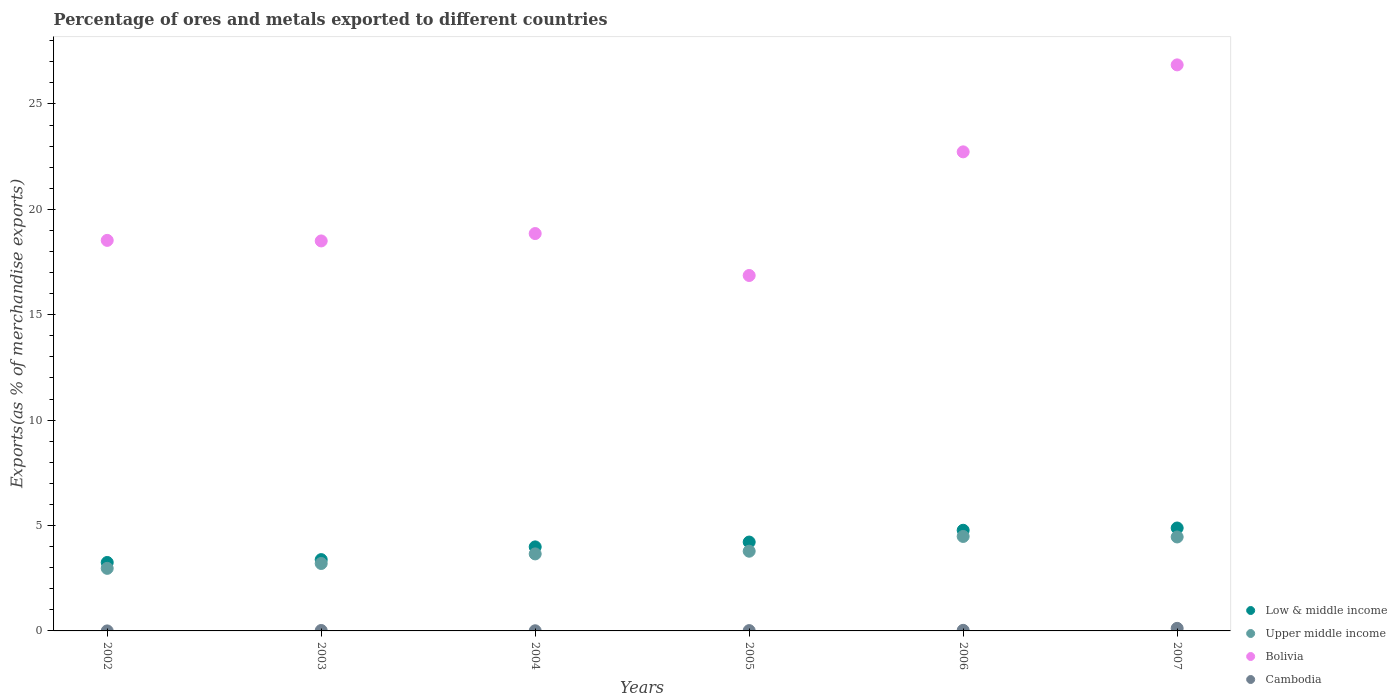How many different coloured dotlines are there?
Your response must be concise. 4. What is the percentage of exports to different countries in Cambodia in 2004?
Make the answer very short. 0.01. Across all years, what is the maximum percentage of exports to different countries in Bolivia?
Ensure brevity in your answer.  26.85. Across all years, what is the minimum percentage of exports to different countries in Cambodia?
Provide a succinct answer. 0. What is the total percentage of exports to different countries in Upper middle income in the graph?
Your response must be concise. 22.54. What is the difference between the percentage of exports to different countries in Low & middle income in 2004 and that in 2006?
Provide a short and direct response. -0.79. What is the difference between the percentage of exports to different countries in Upper middle income in 2004 and the percentage of exports to different countries in Cambodia in 2002?
Keep it short and to the point. 3.65. What is the average percentage of exports to different countries in Upper middle income per year?
Provide a succinct answer. 3.76. In the year 2002, what is the difference between the percentage of exports to different countries in Bolivia and percentage of exports to different countries in Upper middle income?
Your response must be concise. 15.56. In how many years, is the percentage of exports to different countries in Low & middle income greater than 13 %?
Offer a terse response. 0. What is the ratio of the percentage of exports to different countries in Upper middle income in 2002 to that in 2007?
Ensure brevity in your answer.  0.67. What is the difference between the highest and the second highest percentage of exports to different countries in Low & middle income?
Ensure brevity in your answer.  0.11. What is the difference between the highest and the lowest percentage of exports to different countries in Low & middle income?
Your answer should be compact. 1.64. In how many years, is the percentage of exports to different countries in Cambodia greater than the average percentage of exports to different countries in Cambodia taken over all years?
Offer a terse response. 1. Is the sum of the percentage of exports to different countries in Bolivia in 2002 and 2004 greater than the maximum percentage of exports to different countries in Upper middle income across all years?
Keep it short and to the point. Yes. Is it the case that in every year, the sum of the percentage of exports to different countries in Low & middle income and percentage of exports to different countries in Upper middle income  is greater than the sum of percentage of exports to different countries in Bolivia and percentage of exports to different countries in Cambodia?
Provide a succinct answer. No. Is it the case that in every year, the sum of the percentage of exports to different countries in Upper middle income and percentage of exports to different countries in Low & middle income  is greater than the percentage of exports to different countries in Bolivia?
Ensure brevity in your answer.  No. Does the percentage of exports to different countries in Upper middle income monotonically increase over the years?
Offer a very short reply. No. Is the percentage of exports to different countries in Upper middle income strictly greater than the percentage of exports to different countries in Cambodia over the years?
Ensure brevity in your answer.  Yes. Is the percentage of exports to different countries in Cambodia strictly less than the percentage of exports to different countries in Bolivia over the years?
Make the answer very short. Yes. How many years are there in the graph?
Your answer should be compact. 6. What is the difference between two consecutive major ticks on the Y-axis?
Your response must be concise. 5. Does the graph contain grids?
Your answer should be very brief. No. Where does the legend appear in the graph?
Your answer should be compact. Bottom right. How many legend labels are there?
Make the answer very short. 4. What is the title of the graph?
Give a very brief answer. Percentage of ores and metals exported to different countries. Does "Tuvalu" appear as one of the legend labels in the graph?
Offer a very short reply. No. What is the label or title of the Y-axis?
Provide a succinct answer. Exports(as % of merchandise exports). What is the Exports(as % of merchandise exports) in Low & middle income in 2002?
Make the answer very short. 3.25. What is the Exports(as % of merchandise exports) of Upper middle income in 2002?
Make the answer very short. 2.97. What is the Exports(as % of merchandise exports) of Bolivia in 2002?
Offer a terse response. 18.53. What is the Exports(as % of merchandise exports) of Cambodia in 2002?
Ensure brevity in your answer.  0. What is the Exports(as % of merchandise exports) in Low & middle income in 2003?
Your answer should be very brief. 3.38. What is the Exports(as % of merchandise exports) of Upper middle income in 2003?
Ensure brevity in your answer.  3.2. What is the Exports(as % of merchandise exports) of Bolivia in 2003?
Provide a succinct answer. 18.5. What is the Exports(as % of merchandise exports) in Cambodia in 2003?
Offer a very short reply. 0.02. What is the Exports(as % of merchandise exports) of Low & middle income in 2004?
Ensure brevity in your answer.  3.99. What is the Exports(as % of merchandise exports) in Upper middle income in 2004?
Ensure brevity in your answer.  3.65. What is the Exports(as % of merchandise exports) of Bolivia in 2004?
Offer a very short reply. 18.85. What is the Exports(as % of merchandise exports) in Cambodia in 2004?
Give a very brief answer. 0.01. What is the Exports(as % of merchandise exports) of Low & middle income in 2005?
Offer a very short reply. 4.22. What is the Exports(as % of merchandise exports) in Upper middle income in 2005?
Your answer should be compact. 3.78. What is the Exports(as % of merchandise exports) of Bolivia in 2005?
Your answer should be very brief. 16.86. What is the Exports(as % of merchandise exports) of Cambodia in 2005?
Your answer should be very brief. 0.01. What is the Exports(as % of merchandise exports) in Low & middle income in 2006?
Provide a succinct answer. 4.77. What is the Exports(as % of merchandise exports) in Upper middle income in 2006?
Give a very brief answer. 4.48. What is the Exports(as % of merchandise exports) of Bolivia in 2006?
Offer a very short reply. 22.73. What is the Exports(as % of merchandise exports) of Cambodia in 2006?
Offer a very short reply. 0.03. What is the Exports(as % of merchandise exports) of Low & middle income in 2007?
Your answer should be compact. 4.88. What is the Exports(as % of merchandise exports) in Upper middle income in 2007?
Your response must be concise. 4.46. What is the Exports(as % of merchandise exports) of Bolivia in 2007?
Offer a terse response. 26.85. What is the Exports(as % of merchandise exports) of Cambodia in 2007?
Your answer should be compact. 0.12. Across all years, what is the maximum Exports(as % of merchandise exports) in Low & middle income?
Offer a very short reply. 4.88. Across all years, what is the maximum Exports(as % of merchandise exports) of Upper middle income?
Provide a succinct answer. 4.48. Across all years, what is the maximum Exports(as % of merchandise exports) of Bolivia?
Your answer should be compact. 26.85. Across all years, what is the maximum Exports(as % of merchandise exports) of Cambodia?
Offer a very short reply. 0.12. Across all years, what is the minimum Exports(as % of merchandise exports) of Low & middle income?
Give a very brief answer. 3.25. Across all years, what is the minimum Exports(as % of merchandise exports) of Upper middle income?
Your response must be concise. 2.97. Across all years, what is the minimum Exports(as % of merchandise exports) of Bolivia?
Make the answer very short. 16.86. Across all years, what is the minimum Exports(as % of merchandise exports) in Cambodia?
Give a very brief answer. 0. What is the total Exports(as % of merchandise exports) of Low & middle income in the graph?
Offer a very short reply. 24.49. What is the total Exports(as % of merchandise exports) of Upper middle income in the graph?
Offer a very short reply. 22.54. What is the total Exports(as % of merchandise exports) of Bolivia in the graph?
Provide a short and direct response. 122.32. What is the total Exports(as % of merchandise exports) of Cambodia in the graph?
Provide a succinct answer. 0.19. What is the difference between the Exports(as % of merchandise exports) in Low & middle income in 2002 and that in 2003?
Ensure brevity in your answer.  -0.14. What is the difference between the Exports(as % of merchandise exports) in Upper middle income in 2002 and that in 2003?
Provide a short and direct response. -0.23. What is the difference between the Exports(as % of merchandise exports) in Bolivia in 2002 and that in 2003?
Your response must be concise. 0.03. What is the difference between the Exports(as % of merchandise exports) in Cambodia in 2002 and that in 2003?
Ensure brevity in your answer.  -0.02. What is the difference between the Exports(as % of merchandise exports) in Low & middle income in 2002 and that in 2004?
Give a very brief answer. -0.74. What is the difference between the Exports(as % of merchandise exports) of Upper middle income in 2002 and that in 2004?
Offer a terse response. -0.69. What is the difference between the Exports(as % of merchandise exports) in Bolivia in 2002 and that in 2004?
Offer a terse response. -0.32. What is the difference between the Exports(as % of merchandise exports) of Cambodia in 2002 and that in 2004?
Provide a short and direct response. -0.01. What is the difference between the Exports(as % of merchandise exports) in Low & middle income in 2002 and that in 2005?
Your answer should be compact. -0.97. What is the difference between the Exports(as % of merchandise exports) of Upper middle income in 2002 and that in 2005?
Provide a succinct answer. -0.81. What is the difference between the Exports(as % of merchandise exports) of Bolivia in 2002 and that in 2005?
Keep it short and to the point. 1.67. What is the difference between the Exports(as % of merchandise exports) of Cambodia in 2002 and that in 2005?
Provide a succinct answer. -0.01. What is the difference between the Exports(as % of merchandise exports) of Low & middle income in 2002 and that in 2006?
Your answer should be very brief. -1.53. What is the difference between the Exports(as % of merchandise exports) in Upper middle income in 2002 and that in 2006?
Make the answer very short. -1.51. What is the difference between the Exports(as % of merchandise exports) in Bolivia in 2002 and that in 2006?
Provide a succinct answer. -4.2. What is the difference between the Exports(as % of merchandise exports) of Cambodia in 2002 and that in 2006?
Make the answer very short. -0.03. What is the difference between the Exports(as % of merchandise exports) of Low & middle income in 2002 and that in 2007?
Your answer should be compact. -1.64. What is the difference between the Exports(as % of merchandise exports) in Upper middle income in 2002 and that in 2007?
Provide a short and direct response. -1.49. What is the difference between the Exports(as % of merchandise exports) of Bolivia in 2002 and that in 2007?
Keep it short and to the point. -8.33. What is the difference between the Exports(as % of merchandise exports) of Cambodia in 2002 and that in 2007?
Give a very brief answer. -0.12. What is the difference between the Exports(as % of merchandise exports) in Low & middle income in 2003 and that in 2004?
Your answer should be compact. -0.6. What is the difference between the Exports(as % of merchandise exports) of Upper middle income in 2003 and that in 2004?
Offer a very short reply. -0.45. What is the difference between the Exports(as % of merchandise exports) of Bolivia in 2003 and that in 2004?
Give a very brief answer. -0.35. What is the difference between the Exports(as % of merchandise exports) in Cambodia in 2003 and that in 2004?
Give a very brief answer. 0.01. What is the difference between the Exports(as % of merchandise exports) of Low & middle income in 2003 and that in 2005?
Keep it short and to the point. -0.83. What is the difference between the Exports(as % of merchandise exports) of Upper middle income in 2003 and that in 2005?
Make the answer very short. -0.58. What is the difference between the Exports(as % of merchandise exports) of Bolivia in 2003 and that in 2005?
Your answer should be very brief. 1.64. What is the difference between the Exports(as % of merchandise exports) of Cambodia in 2003 and that in 2005?
Your answer should be compact. 0.01. What is the difference between the Exports(as % of merchandise exports) in Low & middle income in 2003 and that in 2006?
Your answer should be compact. -1.39. What is the difference between the Exports(as % of merchandise exports) of Upper middle income in 2003 and that in 2006?
Offer a terse response. -1.28. What is the difference between the Exports(as % of merchandise exports) of Bolivia in 2003 and that in 2006?
Your response must be concise. -4.23. What is the difference between the Exports(as % of merchandise exports) in Cambodia in 2003 and that in 2006?
Your answer should be compact. -0.01. What is the difference between the Exports(as % of merchandise exports) in Low & middle income in 2003 and that in 2007?
Give a very brief answer. -1.5. What is the difference between the Exports(as % of merchandise exports) in Upper middle income in 2003 and that in 2007?
Offer a terse response. -1.26. What is the difference between the Exports(as % of merchandise exports) in Bolivia in 2003 and that in 2007?
Make the answer very short. -8.35. What is the difference between the Exports(as % of merchandise exports) of Cambodia in 2003 and that in 2007?
Offer a terse response. -0.1. What is the difference between the Exports(as % of merchandise exports) of Low & middle income in 2004 and that in 2005?
Provide a succinct answer. -0.23. What is the difference between the Exports(as % of merchandise exports) in Upper middle income in 2004 and that in 2005?
Ensure brevity in your answer.  -0.13. What is the difference between the Exports(as % of merchandise exports) of Bolivia in 2004 and that in 2005?
Offer a terse response. 1.99. What is the difference between the Exports(as % of merchandise exports) of Cambodia in 2004 and that in 2005?
Your response must be concise. -0.01. What is the difference between the Exports(as % of merchandise exports) of Low & middle income in 2004 and that in 2006?
Ensure brevity in your answer.  -0.79. What is the difference between the Exports(as % of merchandise exports) of Upper middle income in 2004 and that in 2006?
Offer a terse response. -0.83. What is the difference between the Exports(as % of merchandise exports) in Bolivia in 2004 and that in 2006?
Offer a terse response. -3.88. What is the difference between the Exports(as % of merchandise exports) of Cambodia in 2004 and that in 2006?
Your response must be concise. -0.02. What is the difference between the Exports(as % of merchandise exports) in Low & middle income in 2004 and that in 2007?
Give a very brief answer. -0.9. What is the difference between the Exports(as % of merchandise exports) of Upper middle income in 2004 and that in 2007?
Your answer should be compact. -0.8. What is the difference between the Exports(as % of merchandise exports) of Bolivia in 2004 and that in 2007?
Give a very brief answer. -8. What is the difference between the Exports(as % of merchandise exports) in Cambodia in 2004 and that in 2007?
Provide a succinct answer. -0.11. What is the difference between the Exports(as % of merchandise exports) in Low & middle income in 2005 and that in 2006?
Keep it short and to the point. -0.56. What is the difference between the Exports(as % of merchandise exports) in Upper middle income in 2005 and that in 2006?
Give a very brief answer. -0.7. What is the difference between the Exports(as % of merchandise exports) of Bolivia in 2005 and that in 2006?
Offer a very short reply. -5.87. What is the difference between the Exports(as % of merchandise exports) of Cambodia in 2005 and that in 2006?
Keep it short and to the point. -0.01. What is the difference between the Exports(as % of merchandise exports) in Low & middle income in 2005 and that in 2007?
Offer a very short reply. -0.67. What is the difference between the Exports(as % of merchandise exports) of Upper middle income in 2005 and that in 2007?
Make the answer very short. -0.68. What is the difference between the Exports(as % of merchandise exports) of Bolivia in 2005 and that in 2007?
Provide a short and direct response. -9.99. What is the difference between the Exports(as % of merchandise exports) of Cambodia in 2005 and that in 2007?
Your response must be concise. -0.11. What is the difference between the Exports(as % of merchandise exports) in Low & middle income in 2006 and that in 2007?
Your answer should be very brief. -0.11. What is the difference between the Exports(as % of merchandise exports) of Upper middle income in 2006 and that in 2007?
Give a very brief answer. 0.02. What is the difference between the Exports(as % of merchandise exports) of Bolivia in 2006 and that in 2007?
Ensure brevity in your answer.  -4.13. What is the difference between the Exports(as % of merchandise exports) in Cambodia in 2006 and that in 2007?
Keep it short and to the point. -0.09. What is the difference between the Exports(as % of merchandise exports) of Low & middle income in 2002 and the Exports(as % of merchandise exports) of Upper middle income in 2003?
Ensure brevity in your answer.  0.05. What is the difference between the Exports(as % of merchandise exports) of Low & middle income in 2002 and the Exports(as % of merchandise exports) of Bolivia in 2003?
Offer a very short reply. -15.25. What is the difference between the Exports(as % of merchandise exports) of Low & middle income in 2002 and the Exports(as % of merchandise exports) of Cambodia in 2003?
Offer a terse response. 3.23. What is the difference between the Exports(as % of merchandise exports) in Upper middle income in 2002 and the Exports(as % of merchandise exports) in Bolivia in 2003?
Ensure brevity in your answer.  -15.53. What is the difference between the Exports(as % of merchandise exports) in Upper middle income in 2002 and the Exports(as % of merchandise exports) in Cambodia in 2003?
Ensure brevity in your answer.  2.95. What is the difference between the Exports(as % of merchandise exports) in Bolivia in 2002 and the Exports(as % of merchandise exports) in Cambodia in 2003?
Your response must be concise. 18.51. What is the difference between the Exports(as % of merchandise exports) of Low & middle income in 2002 and the Exports(as % of merchandise exports) of Upper middle income in 2004?
Provide a short and direct response. -0.41. What is the difference between the Exports(as % of merchandise exports) in Low & middle income in 2002 and the Exports(as % of merchandise exports) in Bolivia in 2004?
Offer a very short reply. -15.6. What is the difference between the Exports(as % of merchandise exports) in Low & middle income in 2002 and the Exports(as % of merchandise exports) in Cambodia in 2004?
Your response must be concise. 3.24. What is the difference between the Exports(as % of merchandise exports) in Upper middle income in 2002 and the Exports(as % of merchandise exports) in Bolivia in 2004?
Ensure brevity in your answer.  -15.88. What is the difference between the Exports(as % of merchandise exports) of Upper middle income in 2002 and the Exports(as % of merchandise exports) of Cambodia in 2004?
Keep it short and to the point. 2.96. What is the difference between the Exports(as % of merchandise exports) in Bolivia in 2002 and the Exports(as % of merchandise exports) in Cambodia in 2004?
Give a very brief answer. 18.52. What is the difference between the Exports(as % of merchandise exports) in Low & middle income in 2002 and the Exports(as % of merchandise exports) in Upper middle income in 2005?
Ensure brevity in your answer.  -0.53. What is the difference between the Exports(as % of merchandise exports) of Low & middle income in 2002 and the Exports(as % of merchandise exports) of Bolivia in 2005?
Offer a very short reply. -13.61. What is the difference between the Exports(as % of merchandise exports) in Low & middle income in 2002 and the Exports(as % of merchandise exports) in Cambodia in 2005?
Provide a short and direct response. 3.23. What is the difference between the Exports(as % of merchandise exports) in Upper middle income in 2002 and the Exports(as % of merchandise exports) in Bolivia in 2005?
Your answer should be very brief. -13.89. What is the difference between the Exports(as % of merchandise exports) of Upper middle income in 2002 and the Exports(as % of merchandise exports) of Cambodia in 2005?
Offer a terse response. 2.95. What is the difference between the Exports(as % of merchandise exports) of Bolivia in 2002 and the Exports(as % of merchandise exports) of Cambodia in 2005?
Give a very brief answer. 18.51. What is the difference between the Exports(as % of merchandise exports) in Low & middle income in 2002 and the Exports(as % of merchandise exports) in Upper middle income in 2006?
Offer a very short reply. -1.23. What is the difference between the Exports(as % of merchandise exports) in Low & middle income in 2002 and the Exports(as % of merchandise exports) in Bolivia in 2006?
Keep it short and to the point. -19.48. What is the difference between the Exports(as % of merchandise exports) of Low & middle income in 2002 and the Exports(as % of merchandise exports) of Cambodia in 2006?
Make the answer very short. 3.22. What is the difference between the Exports(as % of merchandise exports) of Upper middle income in 2002 and the Exports(as % of merchandise exports) of Bolivia in 2006?
Ensure brevity in your answer.  -19.76. What is the difference between the Exports(as % of merchandise exports) of Upper middle income in 2002 and the Exports(as % of merchandise exports) of Cambodia in 2006?
Your answer should be compact. 2.94. What is the difference between the Exports(as % of merchandise exports) of Bolivia in 2002 and the Exports(as % of merchandise exports) of Cambodia in 2006?
Give a very brief answer. 18.5. What is the difference between the Exports(as % of merchandise exports) of Low & middle income in 2002 and the Exports(as % of merchandise exports) of Upper middle income in 2007?
Your answer should be very brief. -1.21. What is the difference between the Exports(as % of merchandise exports) of Low & middle income in 2002 and the Exports(as % of merchandise exports) of Bolivia in 2007?
Your response must be concise. -23.61. What is the difference between the Exports(as % of merchandise exports) of Low & middle income in 2002 and the Exports(as % of merchandise exports) of Cambodia in 2007?
Ensure brevity in your answer.  3.13. What is the difference between the Exports(as % of merchandise exports) of Upper middle income in 2002 and the Exports(as % of merchandise exports) of Bolivia in 2007?
Keep it short and to the point. -23.89. What is the difference between the Exports(as % of merchandise exports) in Upper middle income in 2002 and the Exports(as % of merchandise exports) in Cambodia in 2007?
Offer a very short reply. 2.85. What is the difference between the Exports(as % of merchandise exports) in Bolivia in 2002 and the Exports(as % of merchandise exports) in Cambodia in 2007?
Offer a very short reply. 18.41. What is the difference between the Exports(as % of merchandise exports) in Low & middle income in 2003 and the Exports(as % of merchandise exports) in Upper middle income in 2004?
Make the answer very short. -0.27. What is the difference between the Exports(as % of merchandise exports) of Low & middle income in 2003 and the Exports(as % of merchandise exports) of Bolivia in 2004?
Ensure brevity in your answer.  -15.47. What is the difference between the Exports(as % of merchandise exports) of Low & middle income in 2003 and the Exports(as % of merchandise exports) of Cambodia in 2004?
Provide a short and direct response. 3.38. What is the difference between the Exports(as % of merchandise exports) of Upper middle income in 2003 and the Exports(as % of merchandise exports) of Bolivia in 2004?
Your response must be concise. -15.65. What is the difference between the Exports(as % of merchandise exports) of Upper middle income in 2003 and the Exports(as % of merchandise exports) of Cambodia in 2004?
Your answer should be very brief. 3.19. What is the difference between the Exports(as % of merchandise exports) in Bolivia in 2003 and the Exports(as % of merchandise exports) in Cambodia in 2004?
Your answer should be compact. 18.49. What is the difference between the Exports(as % of merchandise exports) of Low & middle income in 2003 and the Exports(as % of merchandise exports) of Upper middle income in 2005?
Offer a very short reply. -0.4. What is the difference between the Exports(as % of merchandise exports) of Low & middle income in 2003 and the Exports(as % of merchandise exports) of Bolivia in 2005?
Keep it short and to the point. -13.48. What is the difference between the Exports(as % of merchandise exports) in Low & middle income in 2003 and the Exports(as % of merchandise exports) in Cambodia in 2005?
Keep it short and to the point. 3.37. What is the difference between the Exports(as % of merchandise exports) in Upper middle income in 2003 and the Exports(as % of merchandise exports) in Bolivia in 2005?
Keep it short and to the point. -13.66. What is the difference between the Exports(as % of merchandise exports) in Upper middle income in 2003 and the Exports(as % of merchandise exports) in Cambodia in 2005?
Keep it short and to the point. 3.18. What is the difference between the Exports(as % of merchandise exports) in Bolivia in 2003 and the Exports(as % of merchandise exports) in Cambodia in 2005?
Ensure brevity in your answer.  18.49. What is the difference between the Exports(as % of merchandise exports) in Low & middle income in 2003 and the Exports(as % of merchandise exports) in Upper middle income in 2006?
Offer a very short reply. -1.1. What is the difference between the Exports(as % of merchandise exports) of Low & middle income in 2003 and the Exports(as % of merchandise exports) of Bolivia in 2006?
Give a very brief answer. -19.34. What is the difference between the Exports(as % of merchandise exports) in Low & middle income in 2003 and the Exports(as % of merchandise exports) in Cambodia in 2006?
Offer a terse response. 3.36. What is the difference between the Exports(as % of merchandise exports) of Upper middle income in 2003 and the Exports(as % of merchandise exports) of Bolivia in 2006?
Provide a succinct answer. -19.53. What is the difference between the Exports(as % of merchandise exports) of Upper middle income in 2003 and the Exports(as % of merchandise exports) of Cambodia in 2006?
Give a very brief answer. 3.17. What is the difference between the Exports(as % of merchandise exports) in Bolivia in 2003 and the Exports(as % of merchandise exports) in Cambodia in 2006?
Your answer should be very brief. 18.47. What is the difference between the Exports(as % of merchandise exports) of Low & middle income in 2003 and the Exports(as % of merchandise exports) of Upper middle income in 2007?
Offer a very short reply. -1.07. What is the difference between the Exports(as % of merchandise exports) of Low & middle income in 2003 and the Exports(as % of merchandise exports) of Bolivia in 2007?
Your response must be concise. -23.47. What is the difference between the Exports(as % of merchandise exports) of Low & middle income in 2003 and the Exports(as % of merchandise exports) of Cambodia in 2007?
Ensure brevity in your answer.  3.26. What is the difference between the Exports(as % of merchandise exports) in Upper middle income in 2003 and the Exports(as % of merchandise exports) in Bolivia in 2007?
Your response must be concise. -23.65. What is the difference between the Exports(as % of merchandise exports) of Upper middle income in 2003 and the Exports(as % of merchandise exports) of Cambodia in 2007?
Ensure brevity in your answer.  3.08. What is the difference between the Exports(as % of merchandise exports) of Bolivia in 2003 and the Exports(as % of merchandise exports) of Cambodia in 2007?
Ensure brevity in your answer.  18.38. What is the difference between the Exports(as % of merchandise exports) of Low & middle income in 2004 and the Exports(as % of merchandise exports) of Upper middle income in 2005?
Provide a short and direct response. 0.2. What is the difference between the Exports(as % of merchandise exports) in Low & middle income in 2004 and the Exports(as % of merchandise exports) in Bolivia in 2005?
Give a very brief answer. -12.88. What is the difference between the Exports(as % of merchandise exports) in Low & middle income in 2004 and the Exports(as % of merchandise exports) in Cambodia in 2005?
Offer a terse response. 3.97. What is the difference between the Exports(as % of merchandise exports) of Upper middle income in 2004 and the Exports(as % of merchandise exports) of Bolivia in 2005?
Ensure brevity in your answer.  -13.21. What is the difference between the Exports(as % of merchandise exports) in Upper middle income in 2004 and the Exports(as % of merchandise exports) in Cambodia in 2005?
Ensure brevity in your answer.  3.64. What is the difference between the Exports(as % of merchandise exports) of Bolivia in 2004 and the Exports(as % of merchandise exports) of Cambodia in 2005?
Your answer should be compact. 18.84. What is the difference between the Exports(as % of merchandise exports) in Low & middle income in 2004 and the Exports(as % of merchandise exports) in Upper middle income in 2006?
Ensure brevity in your answer.  -0.5. What is the difference between the Exports(as % of merchandise exports) in Low & middle income in 2004 and the Exports(as % of merchandise exports) in Bolivia in 2006?
Offer a very short reply. -18.74. What is the difference between the Exports(as % of merchandise exports) of Low & middle income in 2004 and the Exports(as % of merchandise exports) of Cambodia in 2006?
Your response must be concise. 3.96. What is the difference between the Exports(as % of merchandise exports) of Upper middle income in 2004 and the Exports(as % of merchandise exports) of Bolivia in 2006?
Your answer should be compact. -19.07. What is the difference between the Exports(as % of merchandise exports) of Upper middle income in 2004 and the Exports(as % of merchandise exports) of Cambodia in 2006?
Offer a terse response. 3.63. What is the difference between the Exports(as % of merchandise exports) of Bolivia in 2004 and the Exports(as % of merchandise exports) of Cambodia in 2006?
Keep it short and to the point. 18.82. What is the difference between the Exports(as % of merchandise exports) in Low & middle income in 2004 and the Exports(as % of merchandise exports) in Upper middle income in 2007?
Offer a very short reply. -0.47. What is the difference between the Exports(as % of merchandise exports) in Low & middle income in 2004 and the Exports(as % of merchandise exports) in Bolivia in 2007?
Offer a very short reply. -22.87. What is the difference between the Exports(as % of merchandise exports) in Low & middle income in 2004 and the Exports(as % of merchandise exports) in Cambodia in 2007?
Keep it short and to the point. 3.86. What is the difference between the Exports(as % of merchandise exports) in Upper middle income in 2004 and the Exports(as % of merchandise exports) in Bolivia in 2007?
Your response must be concise. -23.2. What is the difference between the Exports(as % of merchandise exports) in Upper middle income in 2004 and the Exports(as % of merchandise exports) in Cambodia in 2007?
Your answer should be very brief. 3.53. What is the difference between the Exports(as % of merchandise exports) of Bolivia in 2004 and the Exports(as % of merchandise exports) of Cambodia in 2007?
Provide a short and direct response. 18.73. What is the difference between the Exports(as % of merchandise exports) of Low & middle income in 2005 and the Exports(as % of merchandise exports) of Upper middle income in 2006?
Provide a short and direct response. -0.27. What is the difference between the Exports(as % of merchandise exports) in Low & middle income in 2005 and the Exports(as % of merchandise exports) in Bolivia in 2006?
Offer a terse response. -18.51. What is the difference between the Exports(as % of merchandise exports) in Low & middle income in 2005 and the Exports(as % of merchandise exports) in Cambodia in 2006?
Your answer should be compact. 4.19. What is the difference between the Exports(as % of merchandise exports) in Upper middle income in 2005 and the Exports(as % of merchandise exports) in Bolivia in 2006?
Provide a succinct answer. -18.95. What is the difference between the Exports(as % of merchandise exports) in Upper middle income in 2005 and the Exports(as % of merchandise exports) in Cambodia in 2006?
Offer a terse response. 3.75. What is the difference between the Exports(as % of merchandise exports) in Bolivia in 2005 and the Exports(as % of merchandise exports) in Cambodia in 2006?
Offer a very short reply. 16.83. What is the difference between the Exports(as % of merchandise exports) in Low & middle income in 2005 and the Exports(as % of merchandise exports) in Upper middle income in 2007?
Ensure brevity in your answer.  -0.24. What is the difference between the Exports(as % of merchandise exports) in Low & middle income in 2005 and the Exports(as % of merchandise exports) in Bolivia in 2007?
Keep it short and to the point. -22.64. What is the difference between the Exports(as % of merchandise exports) in Low & middle income in 2005 and the Exports(as % of merchandise exports) in Cambodia in 2007?
Provide a succinct answer. 4.09. What is the difference between the Exports(as % of merchandise exports) of Upper middle income in 2005 and the Exports(as % of merchandise exports) of Bolivia in 2007?
Your response must be concise. -23.07. What is the difference between the Exports(as % of merchandise exports) of Upper middle income in 2005 and the Exports(as % of merchandise exports) of Cambodia in 2007?
Your answer should be very brief. 3.66. What is the difference between the Exports(as % of merchandise exports) in Bolivia in 2005 and the Exports(as % of merchandise exports) in Cambodia in 2007?
Keep it short and to the point. 16.74. What is the difference between the Exports(as % of merchandise exports) of Low & middle income in 2006 and the Exports(as % of merchandise exports) of Upper middle income in 2007?
Make the answer very short. 0.32. What is the difference between the Exports(as % of merchandise exports) of Low & middle income in 2006 and the Exports(as % of merchandise exports) of Bolivia in 2007?
Offer a very short reply. -22.08. What is the difference between the Exports(as % of merchandise exports) of Low & middle income in 2006 and the Exports(as % of merchandise exports) of Cambodia in 2007?
Your answer should be compact. 4.65. What is the difference between the Exports(as % of merchandise exports) of Upper middle income in 2006 and the Exports(as % of merchandise exports) of Bolivia in 2007?
Provide a succinct answer. -22.37. What is the difference between the Exports(as % of merchandise exports) in Upper middle income in 2006 and the Exports(as % of merchandise exports) in Cambodia in 2007?
Your answer should be compact. 4.36. What is the difference between the Exports(as % of merchandise exports) of Bolivia in 2006 and the Exports(as % of merchandise exports) of Cambodia in 2007?
Ensure brevity in your answer.  22.61. What is the average Exports(as % of merchandise exports) in Low & middle income per year?
Keep it short and to the point. 4.08. What is the average Exports(as % of merchandise exports) of Upper middle income per year?
Provide a short and direct response. 3.76. What is the average Exports(as % of merchandise exports) in Bolivia per year?
Your response must be concise. 20.39. What is the average Exports(as % of merchandise exports) of Cambodia per year?
Offer a terse response. 0.03. In the year 2002, what is the difference between the Exports(as % of merchandise exports) in Low & middle income and Exports(as % of merchandise exports) in Upper middle income?
Make the answer very short. 0.28. In the year 2002, what is the difference between the Exports(as % of merchandise exports) in Low & middle income and Exports(as % of merchandise exports) in Bolivia?
Make the answer very short. -15.28. In the year 2002, what is the difference between the Exports(as % of merchandise exports) in Low & middle income and Exports(as % of merchandise exports) in Cambodia?
Your answer should be very brief. 3.25. In the year 2002, what is the difference between the Exports(as % of merchandise exports) of Upper middle income and Exports(as % of merchandise exports) of Bolivia?
Give a very brief answer. -15.56. In the year 2002, what is the difference between the Exports(as % of merchandise exports) in Upper middle income and Exports(as % of merchandise exports) in Cambodia?
Make the answer very short. 2.97. In the year 2002, what is the difference between the Exports(as % of merchandise exports) of Bolivia and Exports(as % of merchandise exports) of Cambodia?
Offer a terse response. 18.53. In the year 2003, what is the difference between the Exports(as % of merchandise exports) of Low & middle income and Exports(as % of merchandise exports) of Upper middle income?
Keep it short and to the point. 0.18. In the year 2003, what is the difference between the Exports(as % of merchandise exports) of Low & middle income and Exports(as % of merchandise exports) of Bolivia?
Provide a succinct answer. -15.12. In the year 2003, what is the difference between the Exports(as % of merchandise exports) of Low & middle income and Exports(as % of merchandise exports) of Cambodia?
Your answer should be very brief. 3.36. In the year 2003, what is the difference between the Exports(as % of merchandise exports) of Upper middle income and Exports(as % of merchandise exports) of Bolivia?
Provide a succinct answer. -15.3. In the year 2003, what is the difference between the Exports(as % of merchandise exports) in Upper middle income and Exports(as % of merchandise exports) in Cambodia?
Provide a succinct answer. 3.18. In the year 2003, what is the difference between the Exports(as % of merchandise exports) in Bolivia and Exports(as % of merchandise exports) in Cambodia?
Your response must be concise. 18.48. In the year 2004, what is the difference between the Exports(as % of merchandise exports) in Low & middle income and Exports(as % of merchandise exports) in Upper middle income?
Your response must be concise. 0.33. In the year 2004, what is the difference between the Exports(as % of merchandise exports) of Low & middle income and Exports(as % of merchandise exports) of Bolivia?
Ensure brevity in your answer.  -14.87. In the year 2004, what is the difference between the Exports(as % of merchandise exports) in Low & middle income and Exports(as % of merchandise exports) in Cambodia?
Offer a terse response. 3.98. In the year 2004, what is the difference between the Exports(as % of merchandise exports) of Upper middle income and Exports(as % of merchandise exports) of Bolivia?
Ensure brevity in your answer.  -15.2. In the year 2004, what is the difference between the Exports(as % of merchandise exports) of Upper middle income and Exports(as % of merchandise exports) of Cambodia?
Give a very brief answer. 3.65. In the year 2004, what is the difference between the Exports(as % of merchandise exports) of Bolivia and Exports(as % of merchandise exports) of Cambodia?
Make the answer very short. 18.84. In the year 2005, what is the difference between the Exports(as % of merchandise exports) in Low & middle income and Exports(as % of merchandise exports) in Upper middle income?
Your answer should be very brief. 0.43. In the year 2005, what is the difference between the Exports(as % of merchandise exports) of Low & middle income and Exports(as % of merchandise exports) of Bolivia?
Your response must be concise. -12.65. In the year 2005, what is the difference between the Exports(as % of merchandise exports) in Low & middle income and Exports(as % of merchandise exports) in Cambodia?
Your answer should be very brief. 4.2. In the year 2005, what is the difference between the Exports(as % of merchandise exports) of Upper middle income and Exports(as % of merchandise exports) of Bolivia?
Your response must be concise. -13.08. In the year 2005, what is the difference between the Exports(as % of merchandise exports) in Upper middle income and Exports(as % of merchandise exports) in Cambodia?
Provide a short and direct response. 3.77. In the year 2005, what is the difference between the Exports(as % of merchandise exports) of Bolivia and Exports(as % of merchandise exports) of Cambodia?
Offer a very short reply. 16.85. In the year 2006, what is the difference between the Exports(as % of merchandise exports) of Low & middle income and Exports(as % of merchandise exports) of Upper middle income?
Offer a terse response. 0.29. In the year 2006, what is the difference between the Exports(as % of merchandise exports) in Low & middle income and Exports(as % of merchandise exports) in Bolivia?
Provide a short and direct response. -17.95. In the year 2006, what is the difference between the Exports(as % of merchandise exports) in Low & middle income and Exports(as % of merchandise exports) in Cambodia?
Your response must be concise. 4.75. In the year 2006, what is the difference between the Exports(as % of merchandise exports) in Upper middle income and Exports(as % of merchandise exports) in Bolivia?
Provide a succinct answer. -18.25. In the year 2006, what is the difference between the Exports(as % of merchandise exports) of Upper middle income and Exports(as % of merchandise exports) of Cambodia?
Offer a very short reply. 4.45. In the year 2006, what is the difference between the Exports(as % of merchandise exports) in Bolivia and Exports(as % of merchandise exports) in Cambodia?
Provide a succinct answer. 22.7. In the year 2007, what is the difference between the Exports(as % of merchandise exports) in Low & middle income and Exports(as % of merchandise exports) in Upper middle income?
Offer a terse response. 0.43. In the year 2007, what is the difference between the Exports(as % of merchandise exports) in Low & middle income and Exports(as % of merchandise exports) in Bolivia?
Ensure brevity in your answer.  -21.97. In the year 2007, what is the difference between the Exports(as % of merchandise exports) of Low & middle income and Exports(as % of merchandise exports) of Cambodia?
Make the answer very short. 4.76. In the year 2007, what is the difference between the Exports(as % of merchandise exports) in Upper middle income and Exports(as % of merchandise exports) in Bolivia?
Provide a short and direct response. -22.4. In the year 2007, what is the difference between the Exports(as % of merchandise exports) in Upper middle income and Exports(as % of merchandise exports) in Cambodia?
Your answer should be compact. 4.34. In the year 2007, what is the difference between the Exports(as % of merchandise exports) of Bolivia and Exports(as % of merchandise exports) of Cambodia?
Keep it short and to the point. 26.73. What is the ratio of the Exports(as % of merchandise exports) in Low & middle income in 2002 to that in 2003?
Keep it short and to the point. 0.96. What is the ratio of the Exports(as % of merchandise exports) of Upper middle income in 2002 to that in 2003?
Provide a succinct answer. 0.93. What is the ratio of the Exports(as % of merchandise exports) of Bolivia in 2002 to that in 2003?
Offer a very short reply. 1. What is the ratio of the Exports(as % of merchandise exports) of Cambodia in 2002 to that in 2003?
Provide a short and direct response. 0.03. What is the ratio of the Exports(as % of merchandise exports) in Low & middle income in 2002 to that in 2004?
Keep it short and to the point. 0.81. What is the ratio of the Exports(as % of merchandise exports) of Upper middle income in 2002 to that in 2004?
Your response must be concise. 0.81. What is the ratio of the Exports(as % of merchandise exports) in Bolivia in 2002 to that in 2004?
Provide a succinct answer. 0.98. What is the ratio of the Exports(as % of merchandise exports) of Cambodia in 2002 to that in 2004?
Make the answer very short. 0.08. What is the ratio of the Exports(as % of merchandise exports) of Low & middle income in 2002 to that in 2005?
Ensure brevity in your answer.  0.77. What is the ratio of the Exports(as % of merchandise exports) in Upper middle income in 2002 to that in 2005?
Your response must be concise. 0.78. What is the ratio of the Exports(as % of merchandise exports) of Bolivia in 2002 to that in 2005?
Ensure brevity in your answer.  1.1. What is the ratio of the Exports(as % of merchandise exports) in Cambodia in 2002 to that in 2005?
Make the answer very short. 0.04. What is the ratio of the Exports(as % of merchandise exports) in Low & middle income in 2002 to that in 2006?
Provide a short and direct response. 0.68. What is the ratio of the Exports(as % of merchandise exports) of Upper middle income in 2002 to that in 2006?
Keep it short and to the point. 0.66. What is the ratio of the Exports(as % of merchandise exports) of Bolivia in 2002 to that in 2006?
Your response must be concise. 0.82. What is the ratio of the Exports(as % of merchandise exports) of Cambodia in 2002 to that in 2006?
Your response must be concise. 0.02. What is the ratio of the Exports(as % of merchandise exports) in Low & middle income in 2002 to that in 2007?
Provide a short and direct response. 0.67. What is the ratio of the Exports(as % of merchandise exports) in Upper middle income in 2002 to that in 2007?
Make the answer very short. 0.67. What is the ratio of the Exports(as % of merchandise exports) of Bolivia in 2002 to that in 2007?
Your answer should be very brief. 0.69. What is the ratio of the Exports(as % of merchandise exports) of Cambodia in 2002 to that in 2007?
Provide a short and direct response. 0. What is the ratio of the Exports(as % of merchandise exports) of Low & middle income in 2003 to that in 2004?
Offer a very short reply. 0.85. What is the ratio of the Exports(as % of merchandise exports) in Upper middle income in 2003 to that in 2004?
Give a very brief answer. 0.88. What is the ratio of the Exports(as % of merchandise exports) of Bolivia in 2003 to that in 2004?
Ensure brevity in your answer.  0.98. What is the ratio of the Exports(as % of merchandise exports) in Cambodia in 2003 to that in 2004?
Keep it short and to the point. 2.77. What is the ratio of the Exports(as % of merchandise exports) in Low & middle income in 2003 to that in 2005?
Your answer should be compact. 0.8. What is the ratio of the Exports(as % of merchandise exports) in Upper middle income in 2003 to that in 2005?
Your answer should be compact. 0.85. What is the ratio of the Exports(as % of merchandise exports) in Bolivia in 2003 to that in 2005?
Offer a terse response. 1.1. What is the ratio of the Exports(as % of merchandise exports) in Cambodia in 2003 to that in 2005?
Make the answer very short. 1.35. What is the ratio of the Exports(as % of merchandise exports) of Low & middle income in 2003 to that in 2006?
Provide a succinct answer. 0.71. What is the ratio of the Exports(as % of merchandise exports) in Upper middle income in 2003 to that in 2006?
Offer a very short reply. 0.71. What is the ratio of the Exports(as % of merchandise exports) of Bolivia in 2003 to that in 2006?
Make the answer very short. 0.81. What is the ratio of the Exports(as % of merchandise exports) in Cambodia in 2003 to that in 2006?
Give a very brief answer. 0.73. What is the ratio of the Exports(as % of merchandise exports) of Low & middle income in 2003 to that in 2007?
Make the answer very short. 0.69. What is the ratio of the Exports(as % of merchandise exports) in Upper middle income in 2003 to that in 2007?
Provide a succinct answer. 0.72. What is the ratio of the Exports(as % of merchandise exports) of Bolivia in 2003 to that in 2007?
Ensure brevity in your answer.  0.69. What is the ratio of the Exports(as % of merchandise exports) of Cambodia in 2003 to that in 2007?
Give a very brief answer. 0.17. What is the ratio of the Exports(as % of merchandise exports) in Low & middle income in 2004 to that in 2005?
Provide a succinct answer. 0.95. What is the ratio of the Exports(as % of merchandise exports) in Upper middle income in 2004 to that in 2005?
Keep it short and to the point. 0.97. What is the ratio of the Exports(as % of merchandise exports) in Bolivia in 2004 to that in 2005?
Provide a short and direct response. 1.12. What is the ratio of the Exports(as % of merchandise exports) in Cambodia in 2004 to that in 2005?
Your answer should be compact. 0.49. What is the ratio of the Exports(as % of merchandise exports) in Low & middle income in 2004 to that in 2006?
Ensure brevity in your answer.  0.83. What is the ratio of the Exports(as % of merchandise exports) of Upper middle income in 2004 to that in 2006?
Keep it short and to the point. 0.82. What is the ratio of the Exports(as % of merchandise exports) in Bolivia in 2004 to that in 2006?
Your answer should be very brief. 0.83. What is the ratio of the Exports(as % of merchandise exports) in Cambodia in 2004 to that in 2006?
Offer a terse response. 0.26. What is the ratio of the Exports(as % of merchandise exports) in Low & middle income in 2004 to that in 2007?
Ensure brevity in your answer.  0.82. What is the ratio of the Exports(as % of merchandise exports) of Upper middle income in 2004 to that in 2007?
Your response must be concise. 0.82. What is the ratio of the Exports(as % of merchandise exports) of Bolivia in 2004 to that in 2007?
Ensure brevity in your answer.  0.7. What is the ratio of the Exports(as % of merchandise exports) in Cambodia in 2004 to that in 2007?
Keep it short and to the point. 0.06. What is the ratio of the Exports(as % of merchandise exports) in Low & middle income in 2005 to that in 2006?
Provide a succinct answer. 0.88. What is the ratio of the Exports(as % of merchandise exports) of Upper middle income in 2005 to that in 2006?
Make the answer very short. 0.84. What is the ratio of the Exports(as % of merchandise exports) in Bolivia in 2005 to that in 2006?
Offer a very short reply. 0.74. What is the ratio of the Exports(as % of merchandise exports) in Cambodia in 2005 to that in 2006?
Keep it short and to the point. 0.54. What is the ratio of the Exports(as % of merchandise exports) of Low & middle income in 2005 to that in 2007?
Offer a terse response. 0.86. What is the ratio of the Exports(as % of merchandise exports) of Upper middle income in 2005 to that in 2007?
Your answer should be very brief. 0.85. What is the ratio of the Exports(as % of merchandise exports) in Bolivia in 2005 to that in 2007?
Provide a succinct answer. 0.63. What is the ratio of the Exports(as % of merchandise exports) of Cambodia in 2005 to that in 2007?
Your response must be concise. 0.12. What is the ratio of the Exports(as % of merchandise exports) in Low & middle income in 2006 to that in 2007?
Your answer should be compact. 0.98. What is the ratio of the Exports(as % of merchandise exports) of Bolivia in 2006 to that in 2007?
Your answer should be compact. 0.85. What is the ratio of the Exports(as % of merchandise exports) in Cambodia in 2006 to that in 2007?
Give a very brief answer. 0.23. What is the difference between the highest and the second highest Exports(as % of merchandise exports) in Low & middle income?
Ensure brevity in your answer.  0.11. What is the difference between the highest and the second highest Exports(as % of merchandise exports) in Upper middle income?
Give a very brief answer. 0.02. What is the difference between the highest and the second highest Exports(as % of merchandise exports) in Bolivia?
Provide a short and direct response. 4.13. What is the difference between the highest and the second highest Exports(as % of merchandise exports) in Cambodia?
Ensure brevity in your answer.  0.09. What is the difference between the highest and the lowest Exports(as % of merchandise exports) in Low & middle income?
Your response must be concise. 1.64. What is the difference between the highest and the lowest Exports(as % of merchandise exports) of Upper middle income?
Your answer should be compact. 1.51. What is the difference between the highest and the lowest Exports(as % of merchandise exports) in Bolivia?
Give a very brief answer. 9.99. What is the difference between the highest and the lowest Exports(as % of merchandise exports) in Cambodia?
Provide a short and direct response. 0.12. 